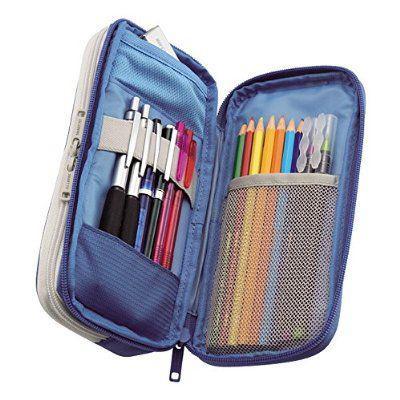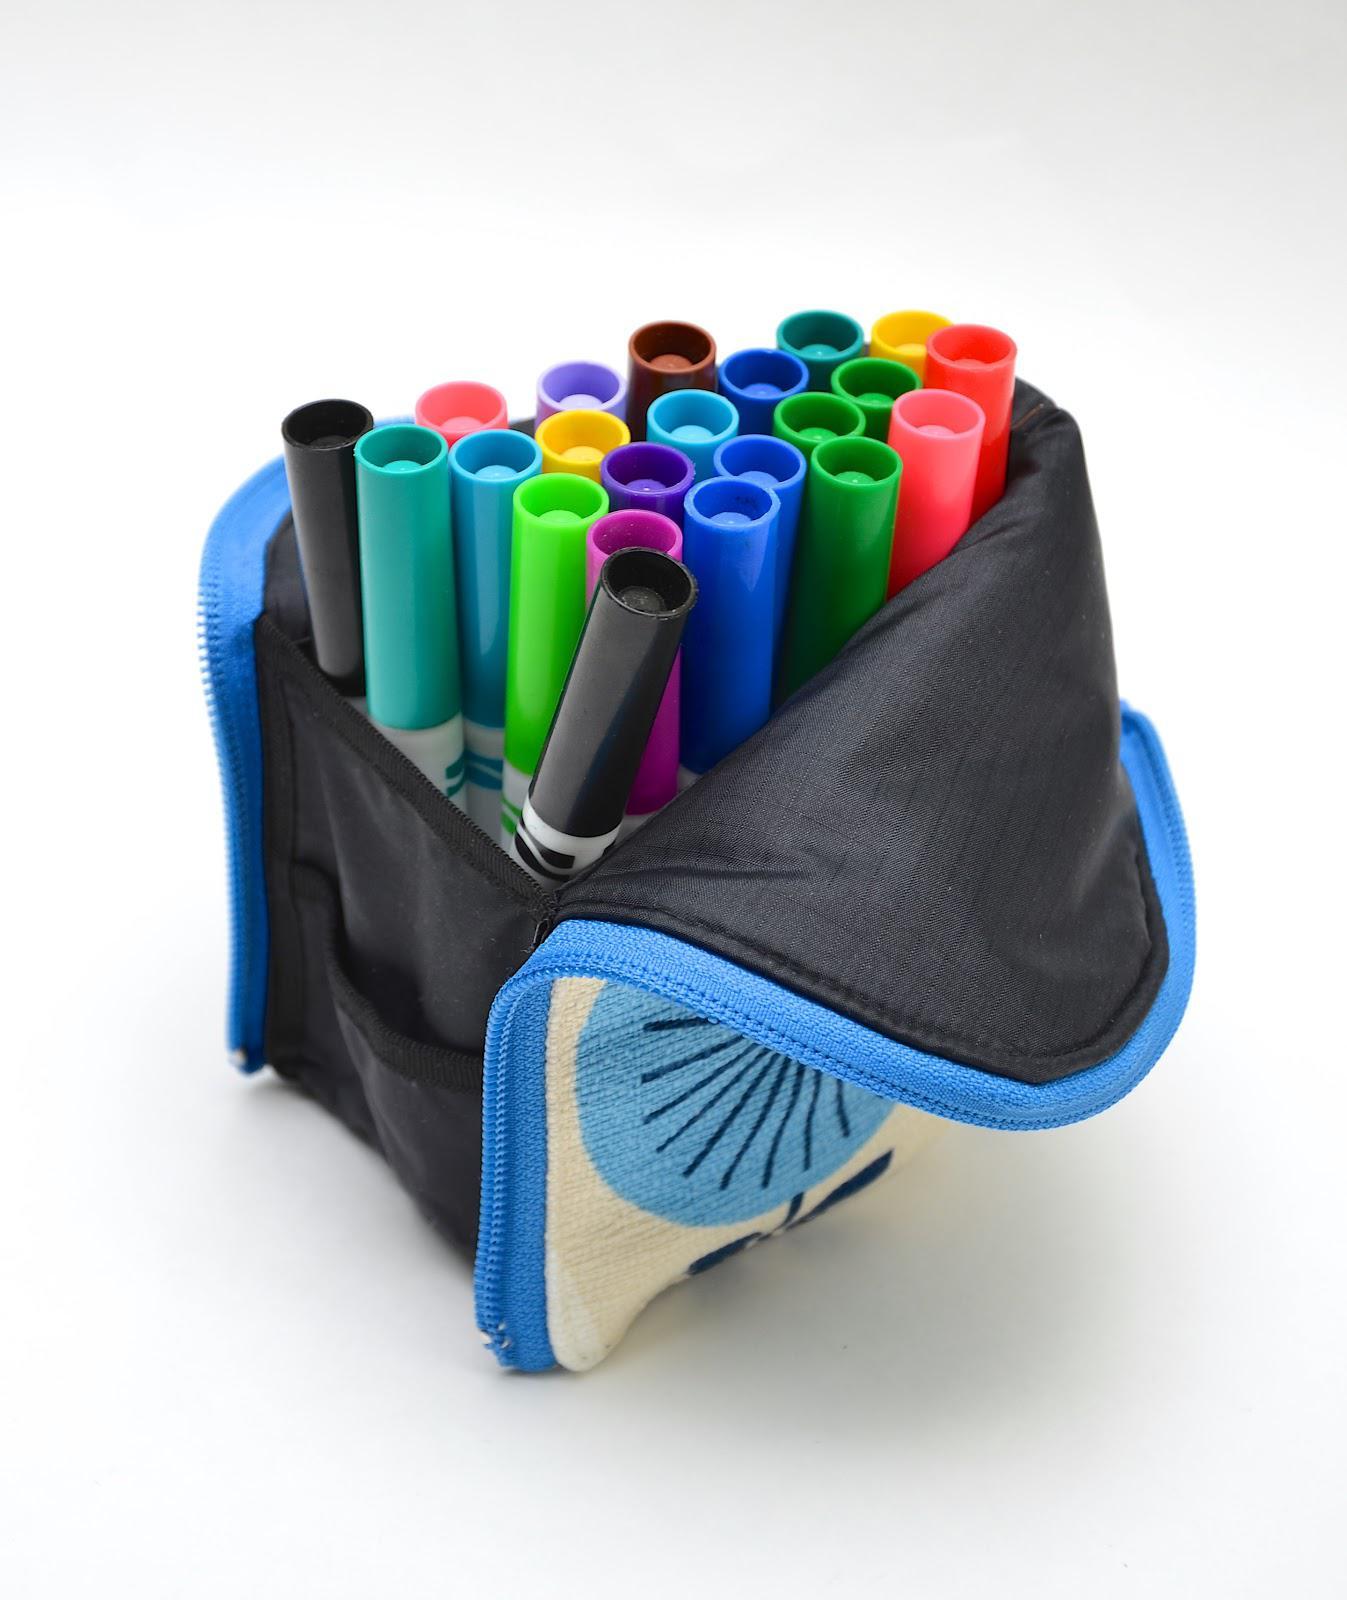The first image is the image on the left, the second image is the image on the right. Evaluate the accuracy of this statement regarding the images: "The right image shows a zipper case with a graphic print on its exterior functioning as an upright holder for colored pencils.". Is it true? Answer yes or no. No. 